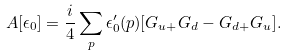Convert formula to latex. <formula><loc_0><loc_0><loc_500><loc_500>A [ \epsilon _ { 0 } ] = \frac { i } { 4 } \sum _ { p } \epsilon ^ { \prime } _ { 0 } ( p ) [ G _ { u + } G _ { d } - G _ { d + } G _ { u } ] .</formula> 